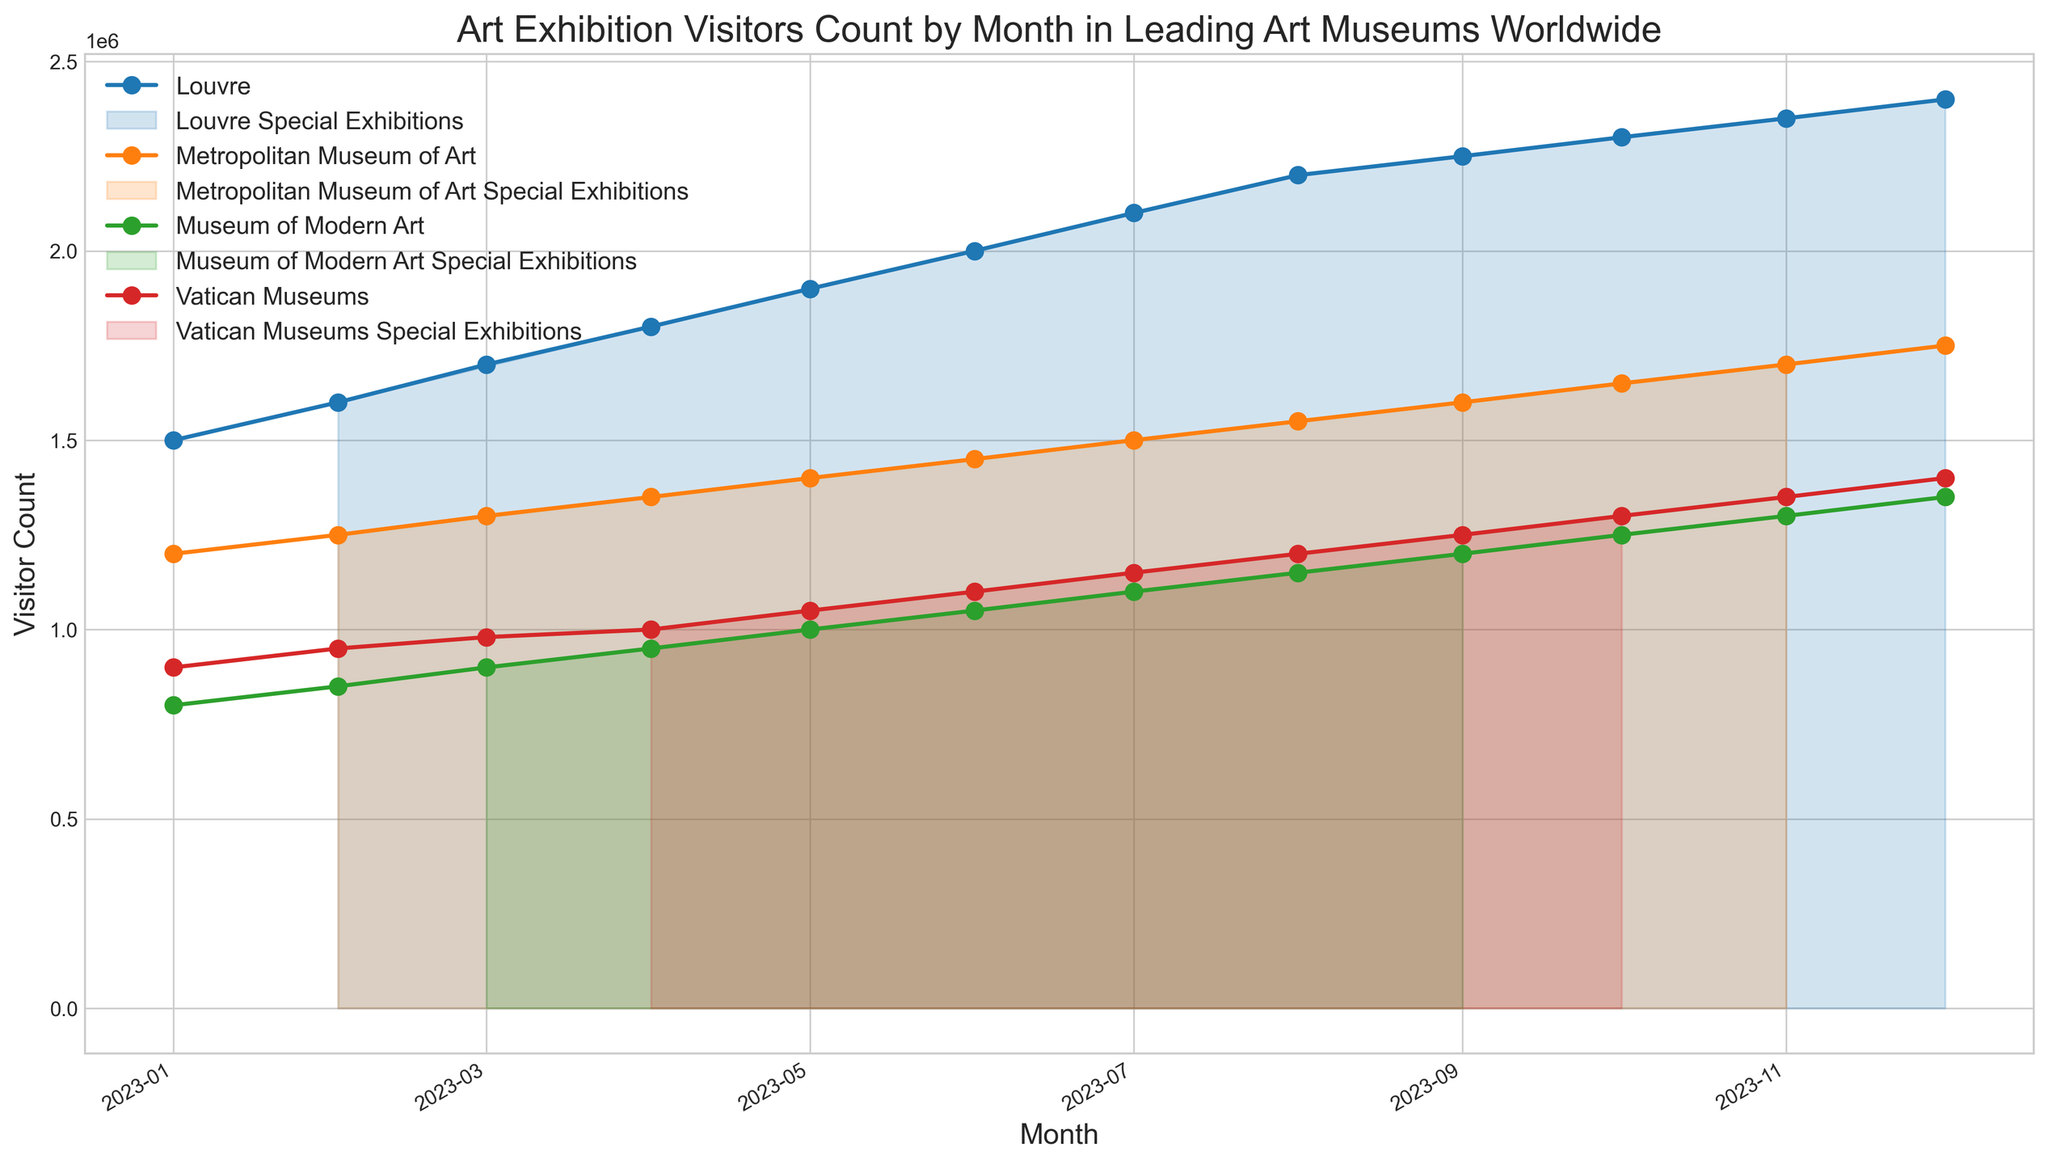Which museum had the highest visitor count in October 2023? To find the museum with the highest visitor count in October 2023, locate October on the x-axis and compare the heights of the lines for that month.
Answer: Louvre Did the Louvre have an increase or decrease in visitors between January and December 2023? Compare the heights of the Louvre's data points in January and December. The December point is higher.
Answer: Increase Which museum had a Special Exhibition in July 2023? Look for a highlighted section (filled area) in July under the respective line representing each museum.
Answer: Metropolitan Museum of Art Calculate the average visitor count for the Vatican Museums in the first quarter of 2023 (January to March). Sum the Vatican Museums' visitor counts for January, February, and March, then divide by 3. (900,000 + 950,000 + 980,000) / 3
Answer: 943,333 Which two museums had an equal visitor count in any month of 2023? Check for overlap in the y-axis values across all museums within the same month.
Answer: Museum of Modern Art and Vatican Museums in October 2023 (both had 1,300,000 visitors) What month did the Museum of Modern Art see the highest visitor count, and how many visitors were there? Identify the highest point on the Museum of Modern Art line and read the corresponding month and y-axis value.
Answer: December 2023, 1,350,000 visitors Was there any month in 2023 where all four museums had a special exhibition at the same time? Look across the months for times when all lines have filled sections. There is no such month.
Answer: No Compare the visitor count trend of the Metropolitan Museum of Art from April to June 2023. Did it increase, decrease, or stay constant? Compare the heights of the data points for the Metropolitan Museum of Art in April, May, and June. It shows an increasing trend.
Answer: Increase How many months in 2023 did the Louvre host special exhibitions, and can you identify these months? Count the filled sections along the Louvre line and identify the corresponding months. The Louvre had special exhibitions in February, April, June, August, October, and December.
Answer: 6 months, February, April, June, August, October, December Identify the museum with the most frequent special exhibitions and how many months they hosted special exhibitions. Count the number of filled sections for each museum and compare. The Louvre had special exhibitions most frequently, hosting them in 6 months.
Answer: Louvre, 6 months 